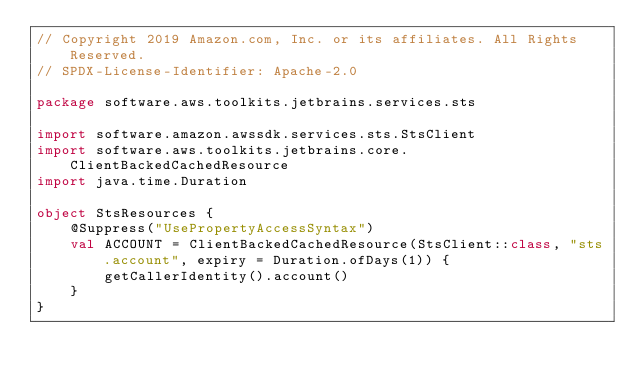<code> <loc_0><loc_0><loc_500><loc_500><_Kotlin_>// Copyright 2019 Amazon.com, Inc. or its affiliates. All Rights Reserved.
// SPDX-License-Identifier: Apache-2.0

package software.aws.toolkits.jetbrains.services.sts

import software.amazon.awssdk.services.sts.StsClient
import software.aws.toolkits.jetbrains.core.ClientBackedCachedResource
import java.time.Duration

object StsResources {
    @Suppress("UsePropertyAccessSyntax")
    val ACCOUNT = ClientBackedCachedResource(StsClient::class, "sts.account", expiry = Duration.ofDays(1)) {
        getCallerIdentity().account()
    }
}</code> 